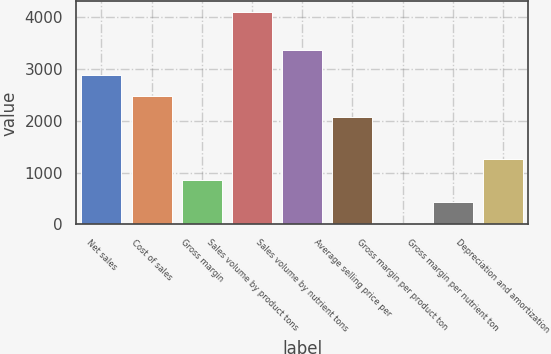Convert chart to OTSL. <chart><loc_0><loc_0><loc_500><loc_500><bar_chart><fcel>Net sales<fcel>Cost of sales<fcel>Gross margin<fcel>Sales volume by product tons<fcel>Sales volume by nutrient tons<fcel>Average selling price per<fcel>Gross margin per product ton<fcel>Gross margin per nutrient ton<fcel>Depreciation and amortization<nl><fcel>2883.7<fcel>2476.6<fcel>848.2<fcel>4105<fcel>3367<fcel>2069.5<fcel>34<fcel>441.1<fcel>1255.3<nl></chart> 